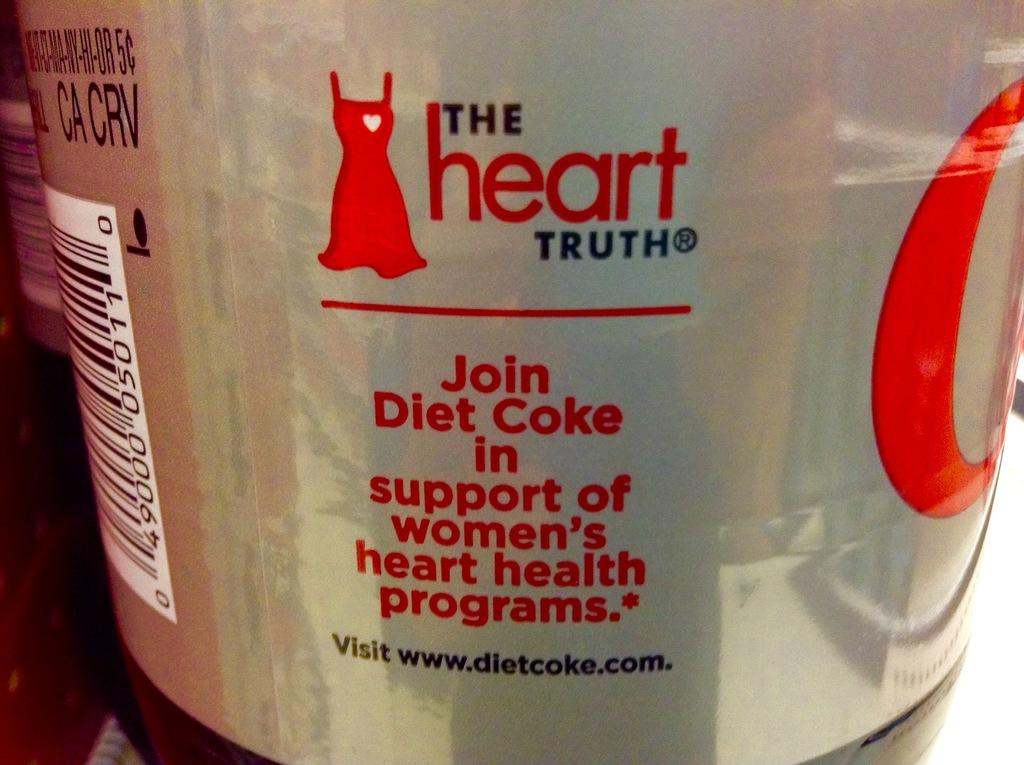Provide a one-sentence caption for the provided image. A close up of a diet coke can. 